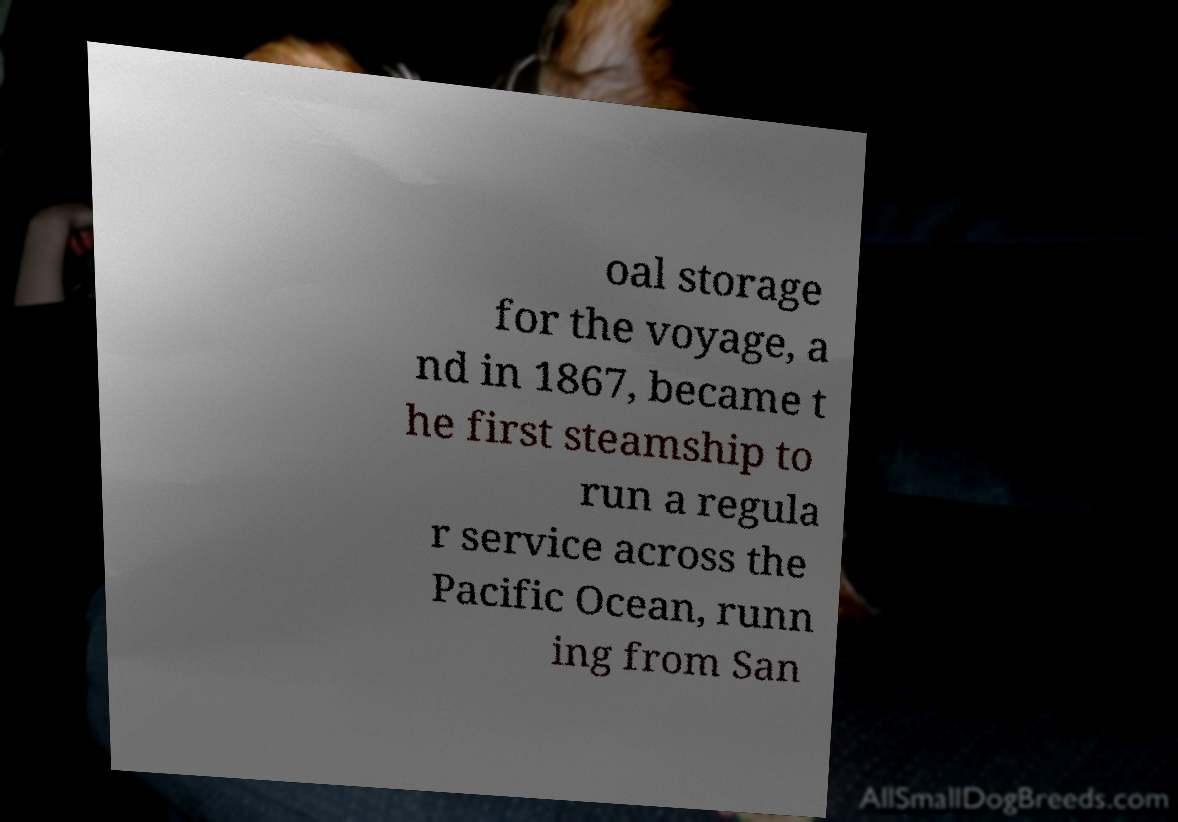Please identify and transcribe the text found in this image. oal storage for the voyage, a nd in 1867, became t he first steamship to run a regula r service across the Pacific Ocean, runn ing from San 